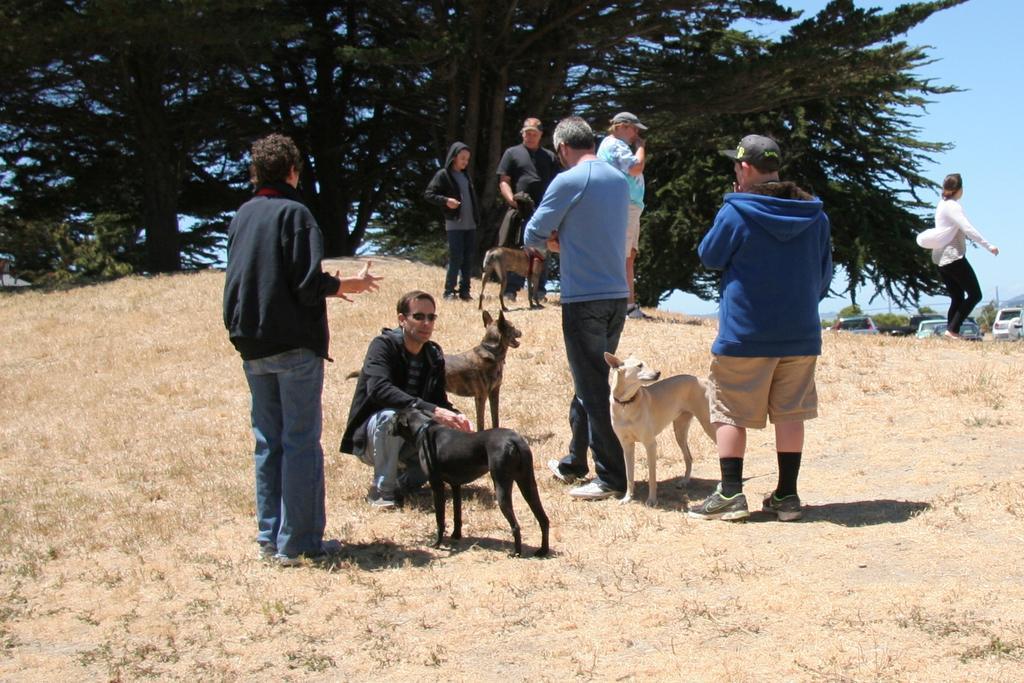Describe this image in one or two sentences. This picture is clicked outside. There are group of people and dogs. To the right corner there is a woman walking. In the background there are group of trees and trucks. 